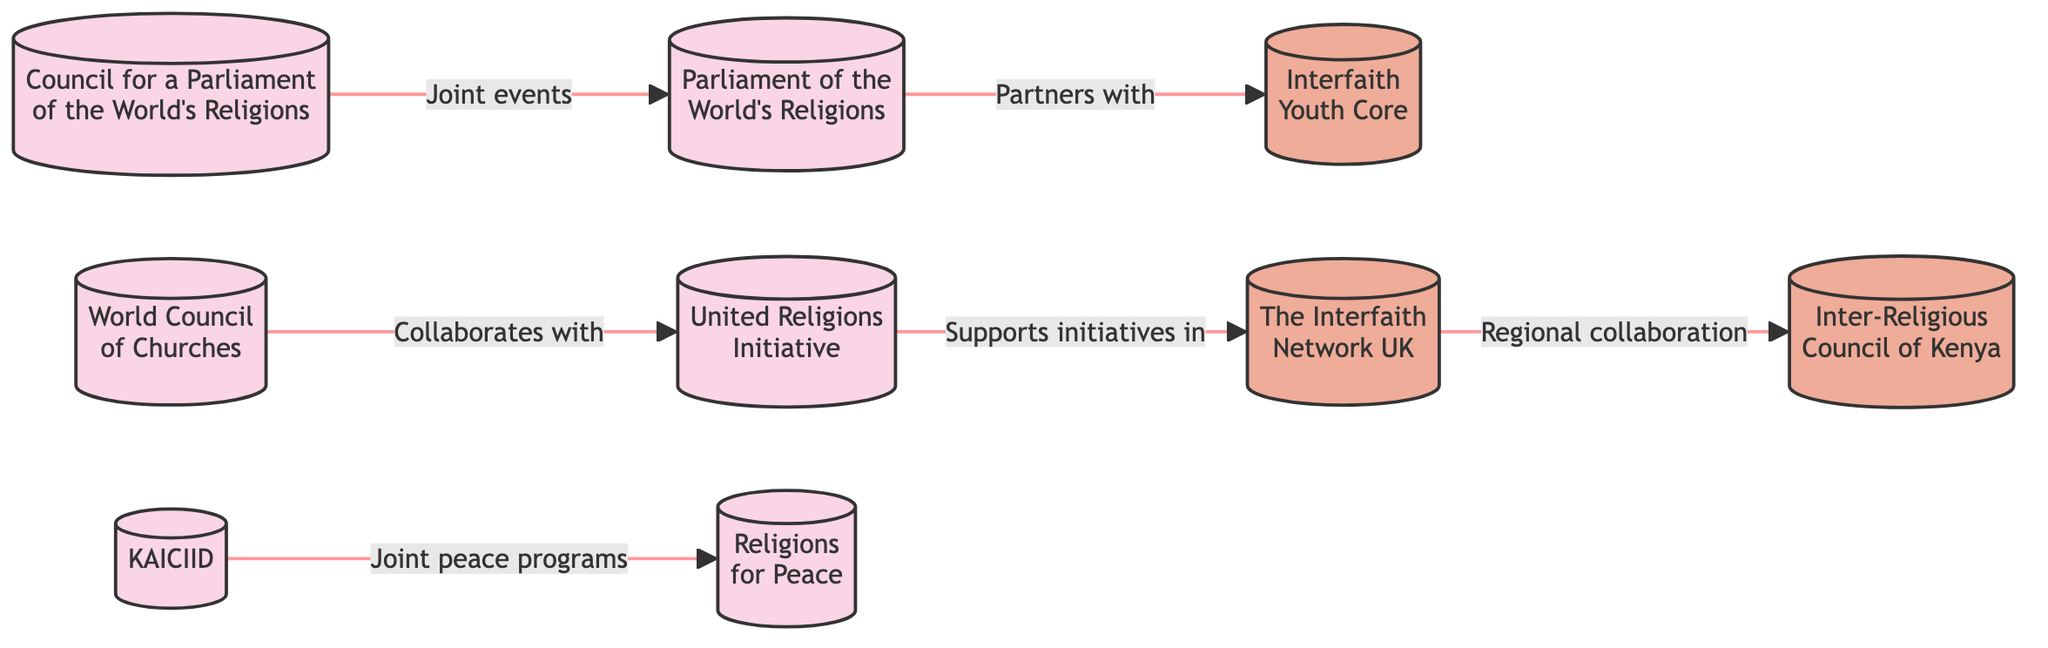What is the total number of interfaith organizations shown in the diagram? The diagram includes nine distinct organizations. By counting each node representing an organization, it’s clear there are nine in total.
Answer: 9 Which organization collaborates with the World Council of Churches? The diagram indicates that the United Religions Initiative collaborates with the World Council of Churches. This is shown by the arrow connecting both organizations.
Answer: United Religions Initiative How many regional organizations are listed in the diagram? There are four organizations categorized as regional, identified by their color in the diagram. By counting the regional nodes, we find a total of four.
Answer: 4 What type of programs does KAICIID engage in with Religions for Peace? The diagram shows that KAICIID engages in joint peace programs with Religions for Peace. This relationship is represented by the line connecting these two nodes.
Answer: Joint peace programs Which organization partners with the Parliament of the World's Religions? The diagram indicates that the Interfaith Youth Core partners with the Parliament of the World's Religions as indicated by the arrow pointing from one to the other.
Answer: Interfaith Youth Core How many organizations are connected to the Council for a Parliament of the World's Religions? The Council for a Parliament of the World's Religions is connected to one other organization, the Parliament of the World's Religions, as shown by the arrow between the two nodes.
Answer: 1 What type of relationship exists between The Interfaith Network UK and the Inter-Religious Council of Kenya? The diagram illustrates that The Interfaith Network UK has a regional collaboration with the Inter-Religious Council of Kenya, which is shown by the line connecting them.
Answer: Regional collaboration Which organization is supported by the United Religions Initiative in its initiatives? The diagram indicates that the United Religions Initiative supports initiatives in The Interfaith Network UK, as demonstrated by the directional arrow from the United Religions Initiative to The Interfaith Network UK.
Answer: The Interfaith Network UK Name one organization that has joint events with the Parliament of the World's Religions. According to the diagram, the Council for a Parliament of the World's Religions has joint events with the Parliament of the World's Religions, indicated by the arrow between these two nodes.
Answer: Council for a Parliament of the World's Religions 